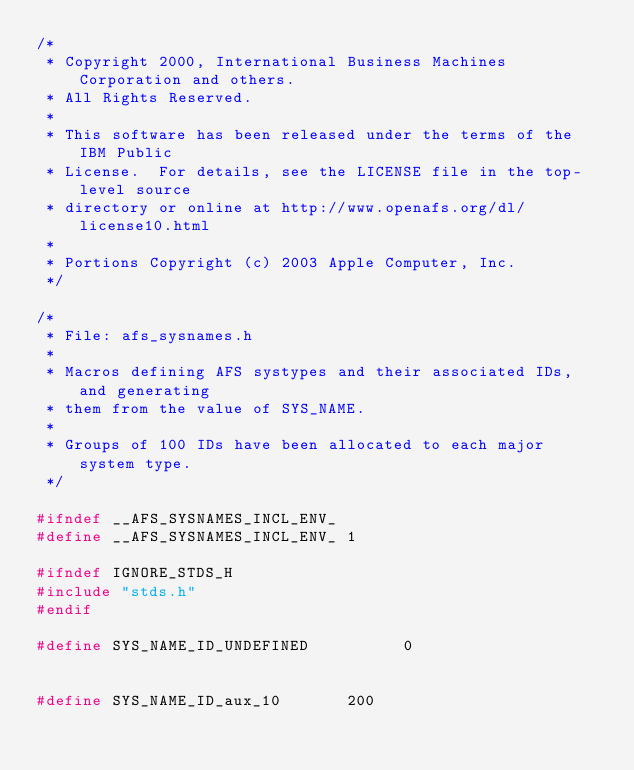<code> <loc_0><loc_0><loc_500><loc_500><_C_>/*
 * Copyright 2000, International Business Machines Corporation and others.
 * All Rights Reserved.
 *
 * This software has been released under the terms of the IBM Public
 * License.  For details, see the LICENSE file in the top-level source
 * directory or online at http://www.openafs.org/dl/license10.html
 *
 * Portions Copyright (c) 2003 Apple Computer, Inc.
 */

/*
 * File: afs_sysnames.h
 *
 * Macros defining AFS systypes and their associated IDs, and generating
 * them from the value of SYS_NAME.
 *
 * Groups of 100 IDs have been allocated to each major system type.
 */

#ifndef __AFS_SYSNAMES_INCL_ENV_
#define __AFS_SYSNAMES_INCL_ENV_ 1

#ifndef	IGNORE_STDS_H
#include "stds.h"
#endif

#define	SYS_NAME_ID_UNDEFINED		   0


#define SYS_NAME_ID_aux_10		 200
</code> 